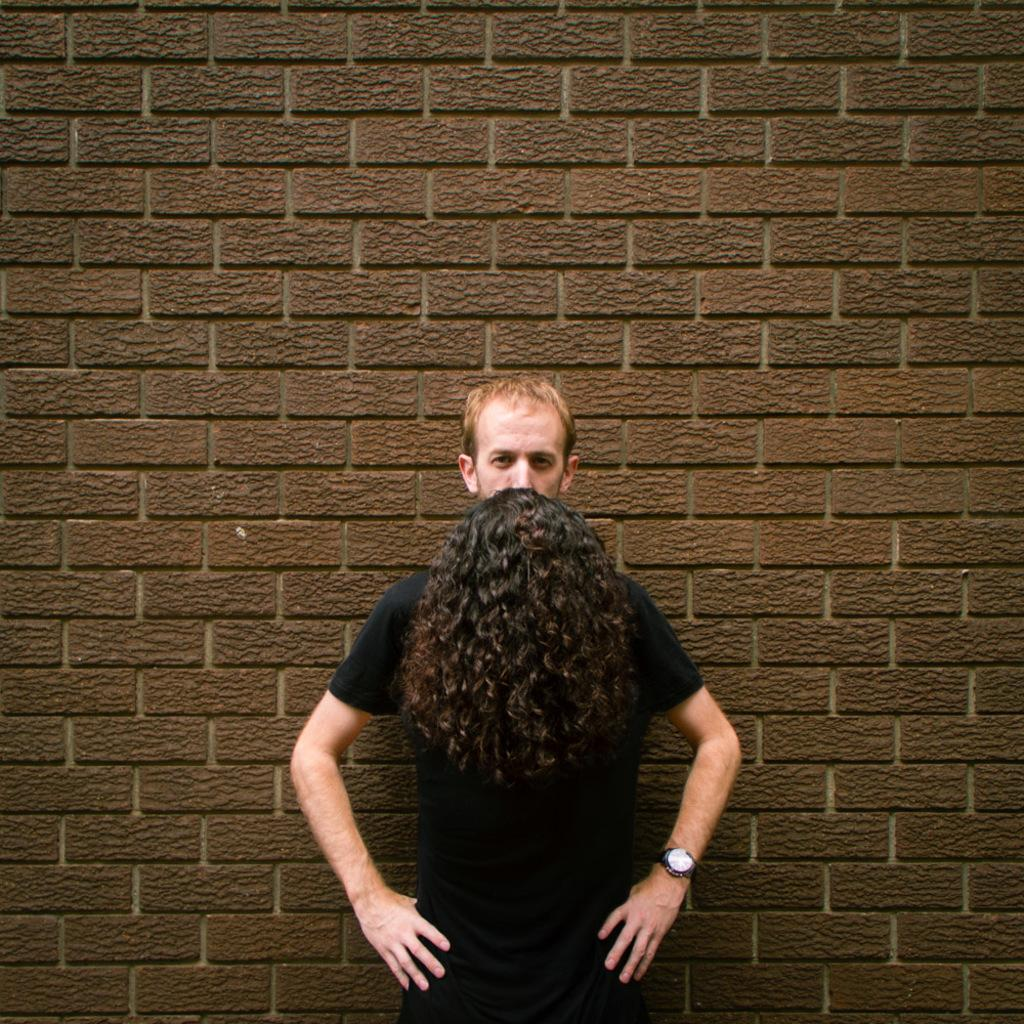Who or what is the main subject in the image? There is a person in the center of the image. What is the person wearing on their head? The person is wearing a wig. What can be seen behind the person? There is a wall behind the person. What type of bridge can be seen in the image? There is no bridge present in the image. What is the texture of the whip in the image? There is no whip present in the image. 